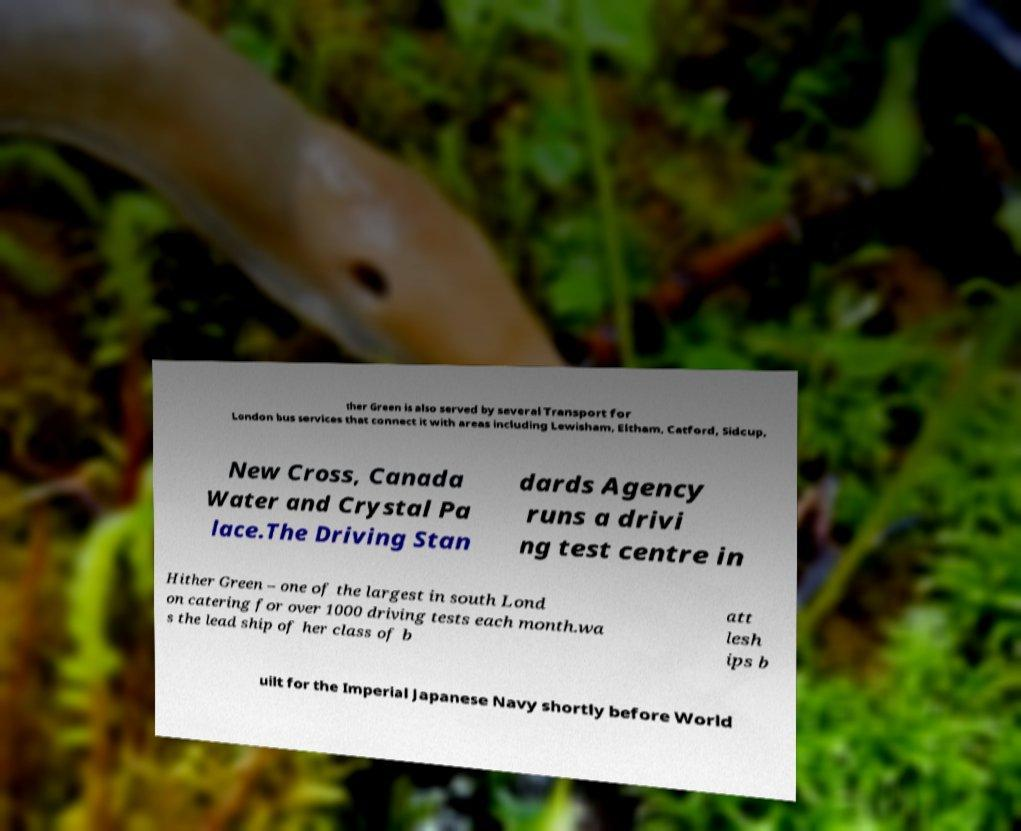Could you extract and type out the text from this image? ther Green is also served by several Transport for London bus services that connect it with areas including Lewisham, Eltham, Catford, Sidcup, New Cross, Canada Water and Crystal Pa lace.The Driving Stan dards Agency runs a drivi ng test centre in Hither Green – one of the largest in south Lond on catering for over 1000 driving tests each month.wa s the lead ship of her class of b att lesh ips b uilt for the Imperial Japanese Navy shortly before World 